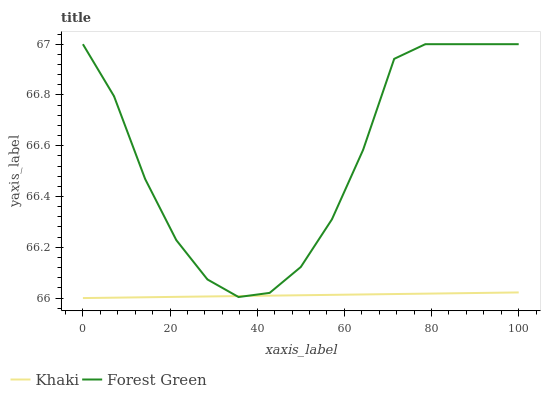Does Khaki have the minimum area under the curve?
Answer yes or no. Yes. Does Forest Green have the maximum area under the curve?
Answer yes or no. Yes. Does Khaki have the maximum area under the curve?
Answer yes or no. No. Is Khaki the smoothest?
Answer yes or no. Yes. Is Forest Green the roughest?
Answer yes or no. Yes. Is Khaki the roughest?
Answer yes or no. No. Does Forest Green have the highest value?
Answer yes or no. Yes. Does Khaki have the highest value?
Answer yes or no. No. 